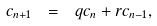<formula> <loc_0><loc_0><loc_500><loc_500>c _ { n + 1 } \ = \ q c _ { n } + r c _ { n - 1 } ,</formula> 